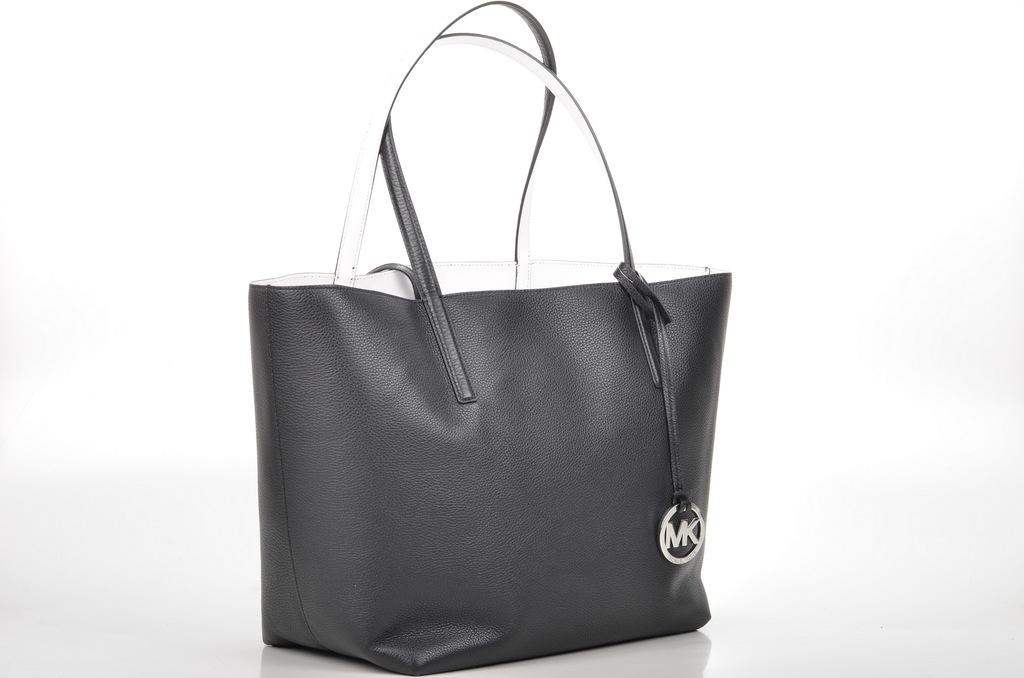What type of accessory is present in the image? There is a handbag in the image. What color is the handbag? The handbag is black in color. How many turkeys are visible in the image? There are no turkeys present in the image. What type of slip is being worn by the handbag in the image? The handbag is an inanimate object and does not wear any clothing, including slips. 